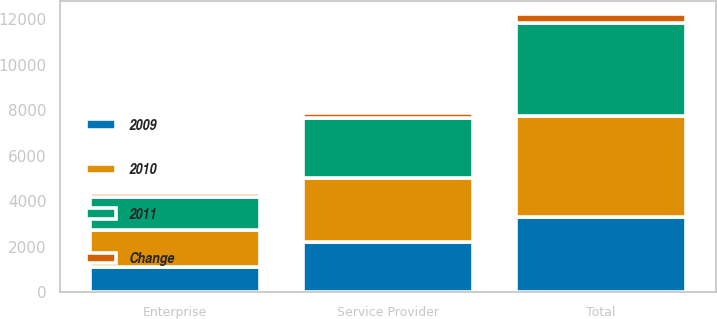Convert chart. <chart><loc_0><loc_0><loc_500><loc_500><stacked_bar_chart><ecel><fcel>Service Provider<fcel>Enterprise<fcel>Total<nl><fcel>2010<fcel>2833<fcel>1615.7<fcel>4448.7<nl><fcel>2011<fcel>2631.5<fcel>1461.8<fcel>4093.3<nl><fcel>Change<fcel>201.5<fcel>153.9<fcel>355.4<nl><fcel>2009<fcel>2197.1<fcel>1118.8<fcel>3315.9<nl></chart> 